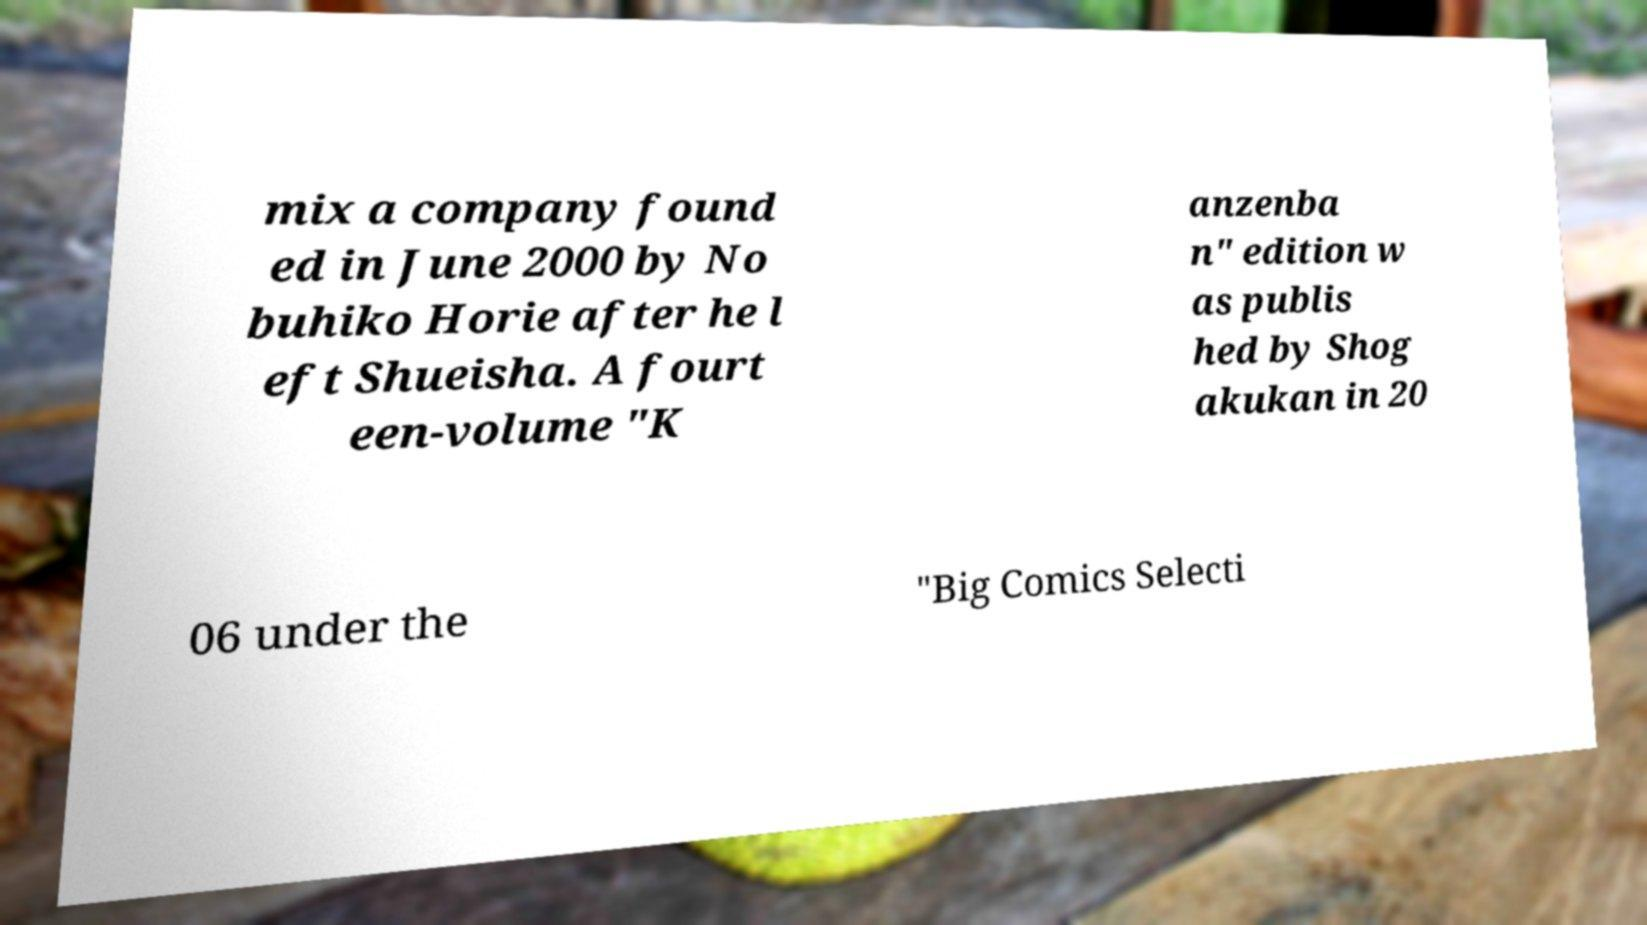Could you extract and type out the text from this image? mix a company found ed in June 2000 by No buhiko Horie after he l eft Shueisha. A fourt een-volume "K anzenba n" edition w as publis hed by Shog akukan in 20 06 under the "Big Comics Selecti 